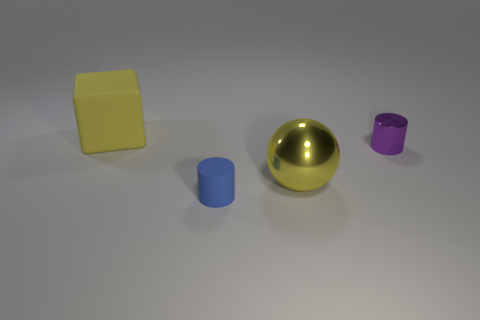There is a object that is both behind the large yellow metal thing and in front of the large yellow block; what color is it?
Your answer should be compact. Purple. What number of balls are either purple metal things or big matte things?
Your answer should be compact. 0. What number of blue things have the same size as the matte cylinder?
Ensure brevity in your answer.  0. There is a tiny cylinder that is on the left side of the yellow sphere; how many yellow shiny things are behind it?
Make the answer very short. 1. There is a object that is both on the left side of the big metal ball and in front of the large matte object; what size is it?
Your response must be concise. Small. Are there more cylinders than shiny balls?
Your response must be concise. Yes. Are there any large rubber objects of the same color as the big metallic sphere?
Keep it short and to the point. Yes. Does the yellow thing that is right of the cube have the same size as the cube?
Your answer should be very brief. Yes. Is the number of small blue cylinders less than the number of small green metallic objects?
Your answer should be very brief. No. Are there any gray blocks that have the same material as the large sphere?
Your response must be concise. No. 